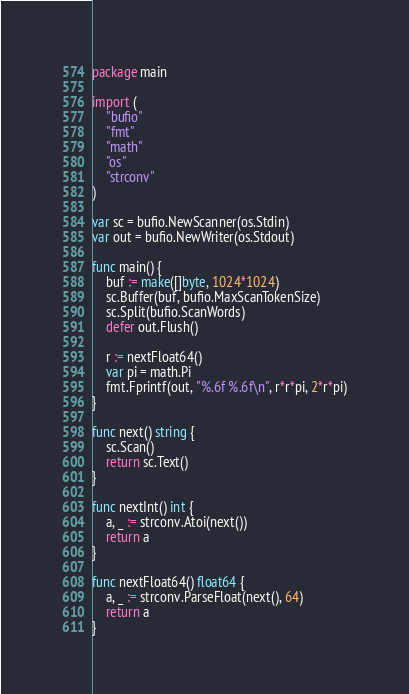<code> <loc_0><loc_0><loc_500><loc_500><_Go_>package main

import (
	"bufio"
	"fmt"
	"math"
	"os"
	"strconv"
)

var sc = bufio.NewScanner(os.Stdin)
var out = bufio.NewWriter(os.Stdout)

func main() {
	buf := make([]byte, 1024*1024)
	sc.Buffer(buf, bufio.MaxScanTokenSize)
	sc.Split(bufio.ScanWords)
	defer out.Flush()

	r := nextFloat64()
	var pi = math.Pi
	fmt.Fprintf(out, "%.6f %.6f\n", r*r*pi, 2*r*pi)
}

func next() string {
	sc.Scan()
	return sc.Text()
}

func nextInt() int {
	a, _ := strconv.Atoi(next())
	return a
}

func nextFloat64() float64 {
	a, _ := strconv.ParseFloat(next(), 64)
	return a
}

</code> 